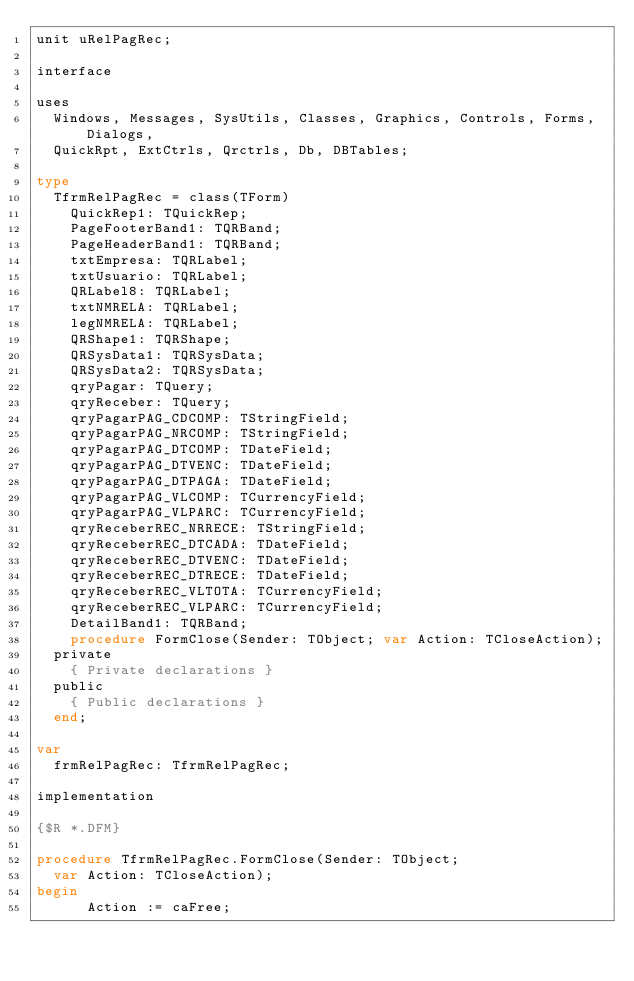<code> <loc_0><loc_0><loc_500><loc_500><_Pascal_>unit uRelPagRec;

interface

uses
  Windows, Messages, SysUtils, Classes, Graphics, Controls, Forms, Dialogs,
  QuickRpt, ExtCtrls, Qrctrls, Db, DBTables;

type
  TfrmRelPagRec = class(TForm)
    QuickRep1: TQuickRep;
    PageFooterBand1: TQRBand;
    PageHeaderBand1: TQRBand;
    txtEmpresa: TQRLabel;
    txtUsuario: TQRLabel;
    QRLabel8: TQRLabel;
    txtNMRELA: TQRLabel;
    legNMRELA: TQRLabel;
    QRShape1: TQRShape;
    QRSysData1: TQRSysData;
    QRSysData2: TQRSysData;
    qryPagar: TQuery;
    qryReceber: TQuery;
    qryPagarPAG_CDCOMP: TStringField;
    qryPagarPAG_NRCOMP: TStringField;
    qryPagarPAG_DTCOMP: TDateField;
    qryPagarPAG_DTVENC: TDateField;
    qryPagarPAG_DTPAGA: TDateField;
    qryPagarPAG_VLCOMP: TCurrencyField;
    qryPagarPAG_VLPARC: TCurrencyField;
    qryReceberREC_NRRECE: TStringField;
    qryReceberREC_DTCADA: TDateField;
    qryReceberREC_DTVENC: TDateField;
    qryReceberREC_DTRECE: TDateField;
    qryReceberREC_VLTOTA: TCurrencyField;
    qryReceberREC_VLPARC: TCurrencyField;
    DetailBand1: TQRBand;
    procedure FormClose(Sender: TObject; var Action: TCloseAction);
  private
    { Private declarations }
  public
    { Public declarations }
  end;

var
  frmRelPagRec: TfrmRelPagRec;

implementation

{$R *.DFM}

procedure TfrmRelPagRec.FormClose(Sender: TObject;
  var Action: TCloseAction);
begin
      Action := caFree;</code> 